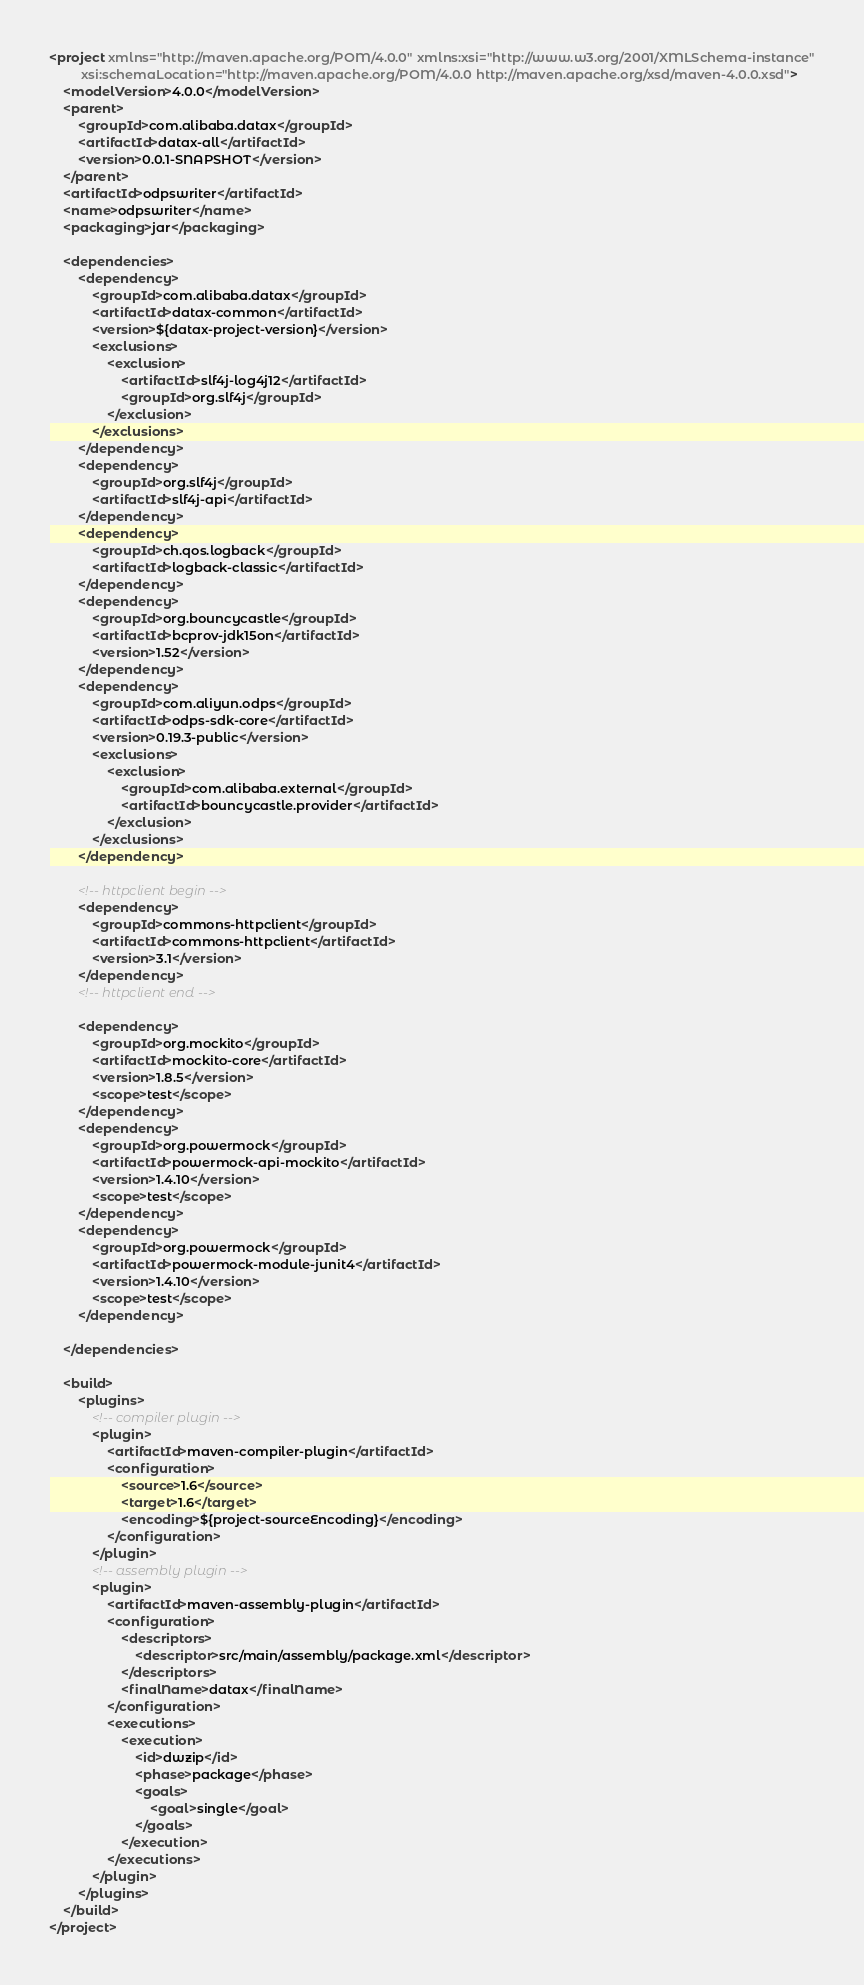<code> <loc_0><loc_0><loc_500><loc_500><_XML_><project xmlns="http://maven.apache.org/POM/4.0.0" xmlns:xsi="http://www.w3.org/2001/XMLSchema-instance"
         xsi:schemaLocation="http://maven.apache.org/POM/4.0.0 http://maven.apache.org/xsd/maven-4.0.0.xsd">
    <modelVersion>4.0.0</modelVersion>
    <parent>
        <groupId>com.alibaba.datax</groupId>
        <artifactId>datax-all</artifactId>
        <version>0.0.1-SNAPSHOT</version>
    </parent>
    <artifactId>odpswriter</artifactId>
    <name>odpswriter</name>
    <packaging>jar</packaging>

    <dependencies>
        <dependency>
            <groupId>com.alibaba.datax</groupId>
            <artifactId>datax-common</artifactId>
            <version>${datax-project-version}</version>
            <exclusions>
                <exclusion>
                    <artifactId>slf4j-log4j12</artifactId>
                    <groupId>org.slf4j</groupId>
                </exclusion>
            </exclusions>
        </dependency>
        <dependency>
            <groupId>org.slf4j</groupId>
            <artifactId>slf4j-api</artifactId>
        </dependency>
        <dependency>
            <groupId>ch.qos.logback</groupId>
            <artifactId>logback-classic</artifactId>
        </dependency>
        <dependency>
            <groupId>org.bouncycastle</groupId>
            <artifactId>bcprov-jdk15on</artifactId>
            <version>1.52</version>
        </dependency>
        <dependency>
			<groupId>com.aliyun.odps</groupId>
			<artifactId>odps-sdk-core</artifactId>
			<version>0.19.3-public</version>
            <exclusions>
                <exclusion>
                    <groupId>com.alibaba.external</groupId>
                    <artifactId>bouncycastle.provider</artifactId>
                </exclusion>
            </exclusions>
		</dependency>

        <!-- httpclient begin -->
        <dependency>
            <groupId>commons-httpclient</groupId>
            <artifactId>commons-httpclient</artifactId>
            <version>3.1</version>
        </dependency>
        <!-- httpclient end -->

        <dependency>
            <groupId>org.mockito</groupId>
            <artifactId>mockito-core</artifactId>
            <version>1.8.5</version>
            <scope>test</scope>
        </dependency>
        <dependency>
            <groupId>org.powermock</groupId>
            <artifactId>powermock-api-mockito</artifactId>
            <version>1.4.10</version>
            <scope>test</scope>
        </dependency>
        <dependency>
            <groupId>org.powermock</groupId>
            <artifactId>powermock-module-junit4</artifactId>
            <version>1.4.10</version>
            <scope>test</scope>
        </dependency>

    </dependencies>

    <build>
        <plugins>
            <!-- compiler plugin -->
            <plugin>
                <artifactId>maven-compiler-plugin</artifactId>
                <configuration>
                    <source>1.6</source>
                    <target>1.6</target>
                    <encoding>${project-sourceEncoding}</encoding>
                </configuration>
            </plugin>
            <!-- assembly plugin -->
            <plugin>
                <artifactId>maven-assembly-plugin</artifactId>
                <configuration>
                    <descriptors>
                        <descriptor>src/main/assembly/package.xml</descriptor>
                    </descriptors>
                    <finalName>datax</finalName>
                </configuration>
                <executions>
                    <execution>
                        <id>dwzip</id>
                        <phase>package</phase>
                        <goals>
                            <goal>single</goal>
                        </goals>
                    </execution>
                </executions>
            </plugin>
        </plugins>
    </build>
</project>
</code> 